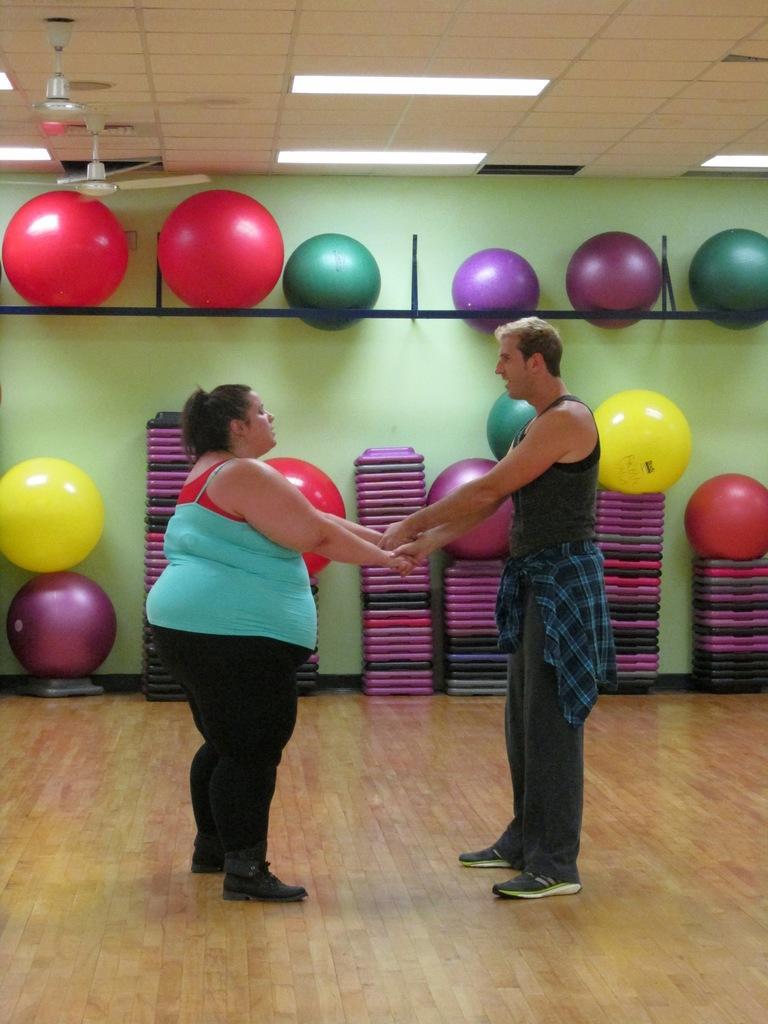Describe this image in one or two sentences. In this image I see a woman and a man who are holding hands and I see that the woman is wearing red and blue top and black pants and this man is wearing black dress and I see the floor. In the background I see the balls which are of different colors and I see few more things over here and I see the green wall and on the ceiling I see the lights and the fans. 